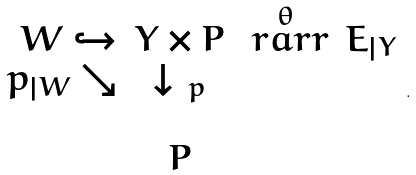Convert formula to latex. <formula><loc_0><loc_0><loc_500><loc_500>\begin{array} { r c c c } W \hookrightarrow & Y \times P & \stackrel { \theta } { \ r a r r } & E _ { | Y } \\ p _ { | W } \searrow & \downarrow \, { _ { p } } & & \\ & & & \\ & P & & \end{array} .</formula> 